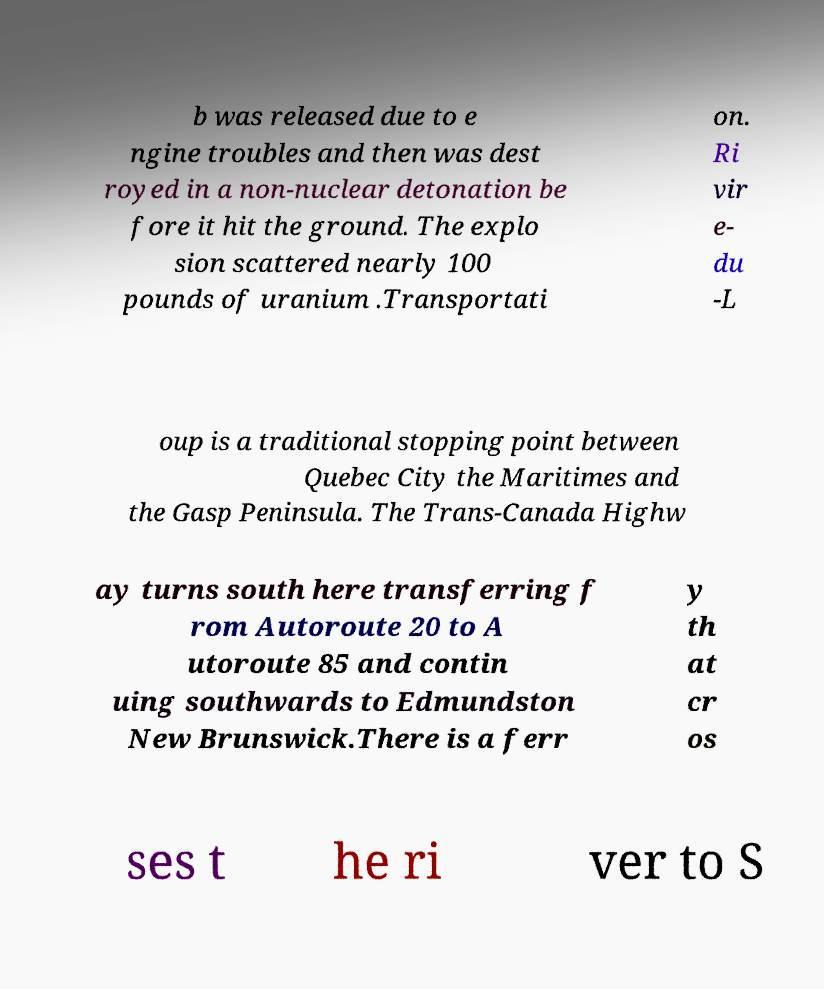For documentation purposes, I need the text within this image transcribed. Could you provide that? b was released due to e ngine troubles and then was dest royed in a non-nuclear detonation be fore it hit the ground. The explo sion scattered nearly 100 pounds of uranium .Transportati on. Ri vir e- du -L oup is a traditional stopping point between Quebec City the Maritimes and the Gasp Peninsula. The Trans-Canada Highw ay turns south here transferring f rom Autoroute 20 to A utoroute 85 and contin uing southwards to Edmundston New Brunswick.There is a ferr y th at cr os ses t he ri ver to S 